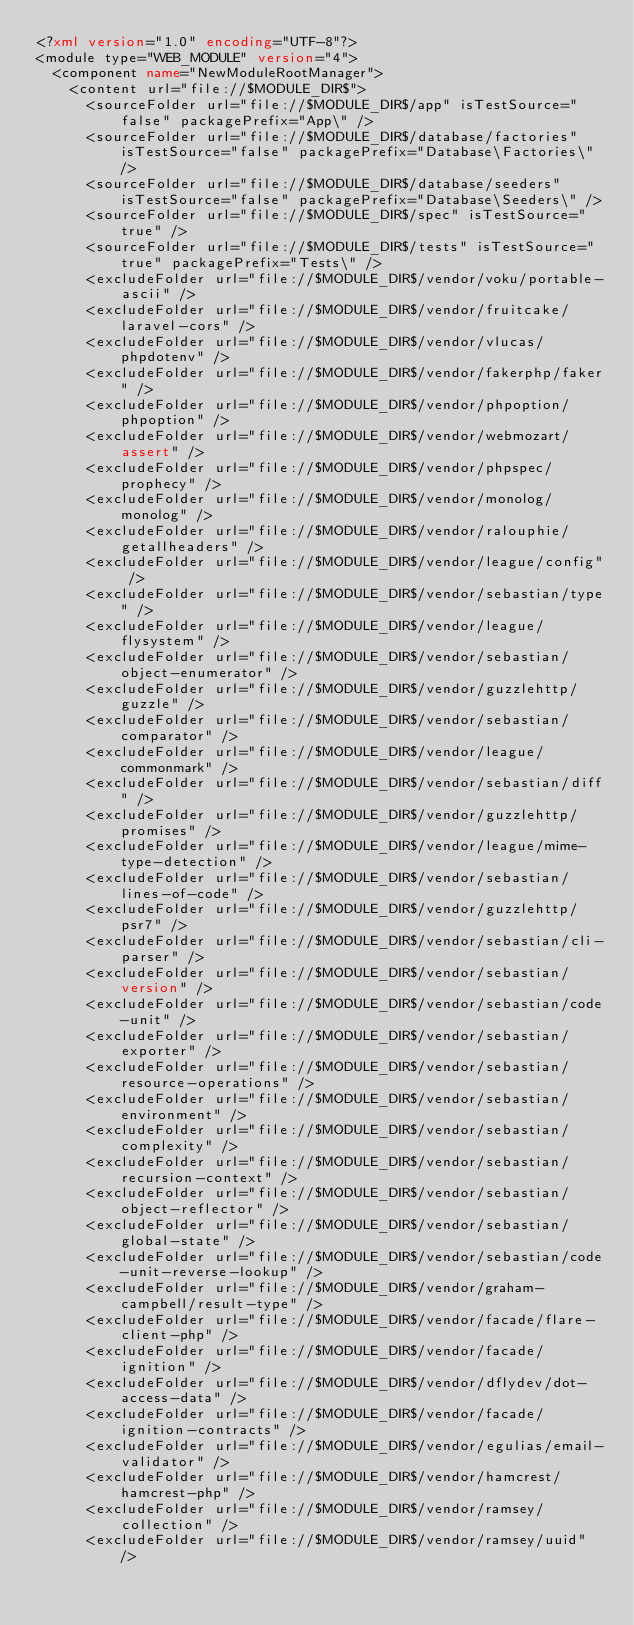<code> <loc_0><loc_0><loc_500><loc_500><_XML_><?xml version="1.0" encoding="UTF-8"?>
<module type="WEB_MODULE" version="4">
  <component name="NewModuleRootManager">
    <content url="file://$MODULE_DIR$">
      <sourceFolder url="file://$MODULE_DIR$/app" isTestSource="false" packagePrefix="App\" />
      <sourceFolder url="file://$MODULE_DIR$/database/factories" isTestSource="false" packagePrefix="Database\Factories\" />
      <sourceFolder url="file://$MODULE_DIR$/database/seeders" isTestSource="false" packagePrefix="Database\Seeders\" />
      <sourceFolder url="file://$MODULE_DIR$/spec" isTestSource="true" />
      <sourceFolder url="file://$MODULE_DIR$/tests" isTestSource="true" packagePrefix="Tests\" />
      <excludeFolder url="file://$MODULE_DIR$/vendor/voku/portable-ascii" />
      <excludeFolder url="file://$MODULE_DIR$/vendor/fruitcake/laravel-cors" />
      <excludeFolder url="file://$MODULE_DIR$/vendor/vlucas/phpdotenv" />
      <excludeFolder url="file://$MODULE_DIR$/vendor/fakerphp/faker" />
      <excludeFolder url="file://$MODULE_DIR$/vendor/phpoption/phpoption" />
      <excludeFolder url="file://$MODULE_DIR$/vendor/webmozart/assert" />
      <excludeFolder url="file://$MODULE_DIR$/vendor/phpspec/prophecy" />
      <excludeFolder url="file://$MODULE_DIR$/vendor/monolog/monolog" />
      <excludeFolder url="file://$MODULE_DIR$/vendor/ralouphie/getallheaders" />
      <excludeFolder url="file://$MODULE_DIR$/vendor/league/config" />
      <excludeFolder url="file://$MODULE_DIR$/vendor/sebastian/type" />
      <excludeFolder url="file://$MODULE_DIR$/vendor/league/flysystem" />
      <excludeFolder url="file://$MODULE_DIR$/vendor/sebastian/object-enumerator" />
      <excludeFolder url="file://$MODULE_DIR$/vendor/guzzlehttp/guzzle" />
      <excludeFolder url="file://$MODULE_DIR$/vendor/sebastian/comparator" />
      <excludeFolder url="file://$MODULE_DIR$/vendor/league/commonmark" />
      <excludeFolder url="file://$MODULE_DIR$/vendor/sebastian/diff" />
      <excludeFolder url="file://$MODULE_DIR$/vendor/guzzlehttp/promises" />
      <excludeFolder url="file://$MODULE_DIR$/vendor/league/mime-type-detection" />
      <excludeFolder url="file://$MODULE_DIR$/vendor/sebastian/lines-of-code" />
      <excludeFolder url="file://$MODULE_DIR$/vendor/guzzlehttp/psr7" />
      <excludeFolder url="file://$MODULE_DIR$/vendor/sebastian/cli-parser" />
      <excludeFolder url="file://$MODULE_DIR$/vendor/sebastian/version" />
      <excludeFolder url="file://$MODULE_DIR$/vendor/sebastian/code-unit" />
      <excludeFolder url="file://$MODULE_DIR$/vendor/sebastian/exporter" />
      <excludeFolder url="file://$MODULE_DIR$/vendor/sebastian/resource-operations" />
      <excludeFolder url="file://$MODULE_DIR$/vendor/sebastian/environment" />
      <excludeFolder url="file://$MODULE_DIR$/vendor/sebastian/complexity" />
      <excludeFolder url="file://$MODULE_DIR$/vendor/sebastian/recursion-context" />
      <excludeFolder url="file://$MODULE_DIR$/vendor/sebastian/object-reflector" />
      <excludeFolder url="file://$MODULE_DIR$/vendor/sebastian/global-state" />
      <excludeFolder url="file://$MODULE_DIR$/vendor/sebastian/code-unit-reverse-lookup" />
      <excludeFolder url="file://$MODULE_DIR$/vendor/graham-campbell/result-type" />
      <excludeFolder url="file://$MODULE_DIR$/vendor/facade/flare-client-php" />
      <excludeFolder url="file://$MODULE_DIR$/vendor/facade/ignition" />
      <excludeFolder url="file://$MODULE_DIR$/vendor/dflydev/dot-access-data" />
      <excludeFolder url="file://$MODULE_DIR$/vendor/facade/ignition-contracts" />
      <excludeFolder url="file://$MODULE_DIR$/vendor/egulias/email-validator" />
      <excludeFolder url="file://$MODULE_DIR$/vendor/hamcrest/hamcrest-php" />
      <excludeFolder url="file://$MODULE_DIR$/vendor/ramsey/collection" />
      <excludeFolder url="file://$MODULE_DIR$/vendor/ramsey/uuid" /></code> 